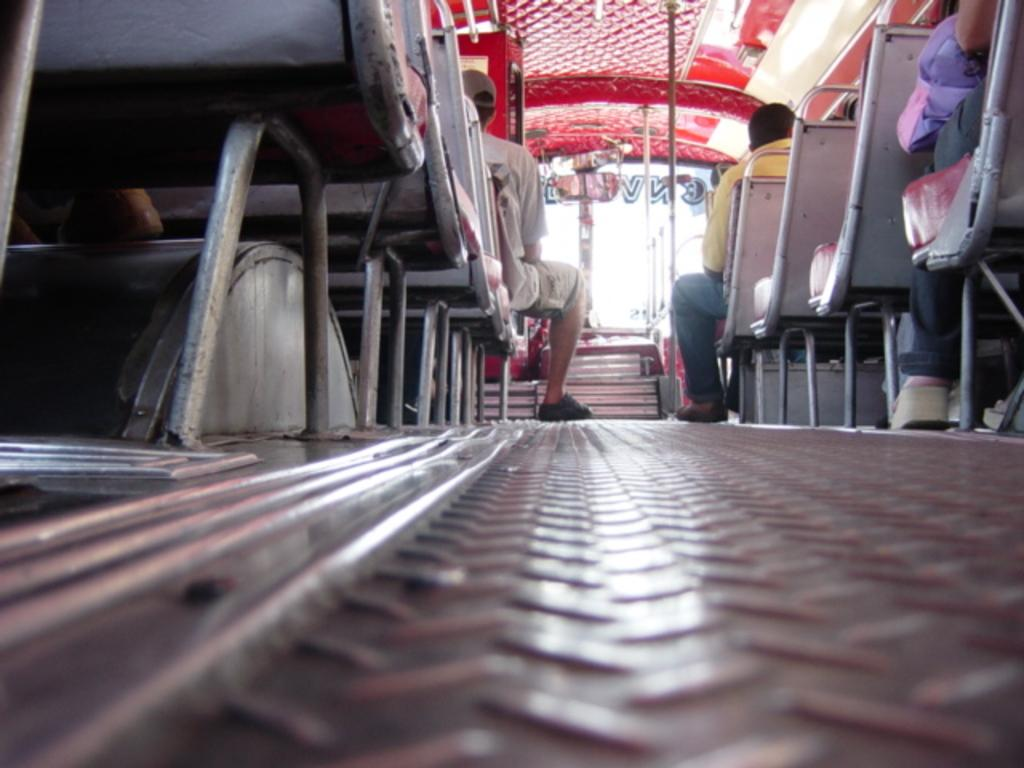What are the people in the image doing? The people in the image are sitting in a vehicle. What objects can be seen in the image besides the people? There are rods visible in the image. What feature is present in the vehicle that might help the driver see behind them? There is a mirror in the vehicle. What is written or displayed on the glass of the vehicle? There is text on the glass of the vehicle. What type of impulse can be seen affecting the knee of the person sitting in the vehicle? There is no impulse or knee visible in the image; it only shows people sitting in a vehicle. 